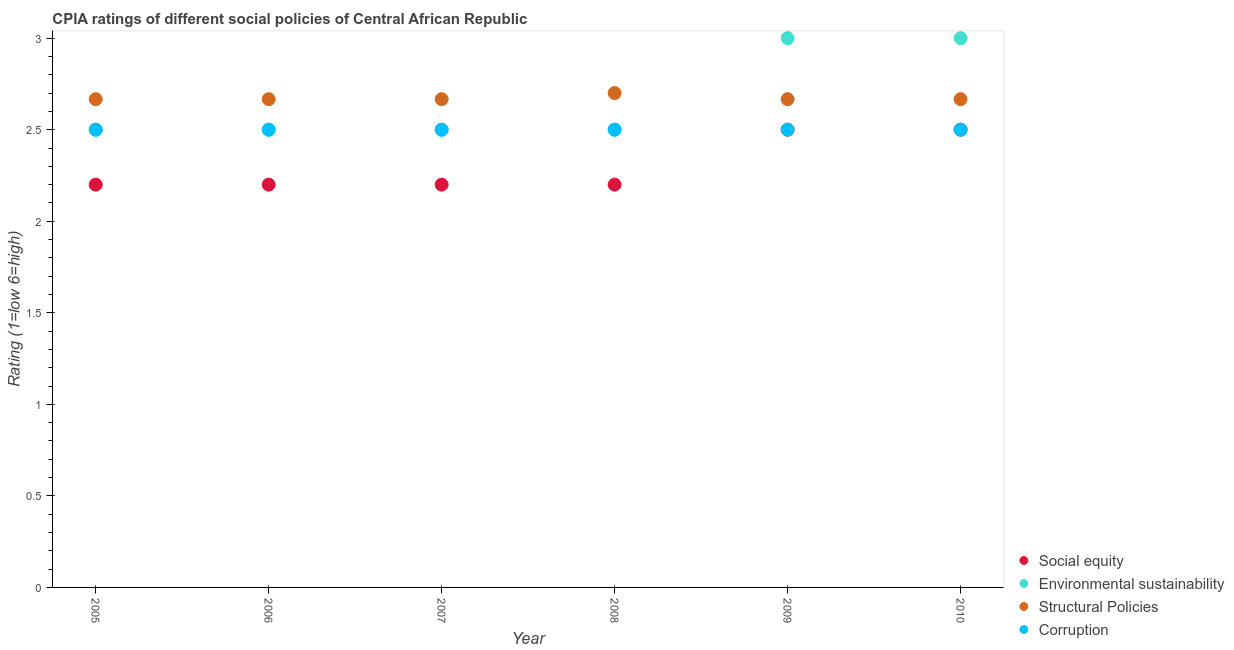Is the number of dotlines equal to the number of legend labels?
Provide a succinct answer. Yes. What is the cpia rating of corruption in 2009?
Offer a very short reply. 2.5. Across all years, what is the maximum cpia rating of structural policies?
Make the answer very short. 2.7. Across all years, what is the minimum cpia rating of structural policies?
Make the answer very short. 2.67. In which year was the cpia rating of social equity maximum?
Offer a terse response. 2009. What is the total cpia rating of structural policies in the graph?
Offer a terse response. 16.03. What is the difference between the cpia rating of social equity in 2006 and that in 2010?
Your answer should be compact. -0.3. What is the difference between the cpia rating of structural policies in 2009 and the cpia rating of social equity in 2005?
Keep it short and to the point. 0.47. What is the average cpia rating of structural policies per year?
Your answer should be compact. 2.67. In the year 2008, what is the difference between the cpia rating of social equity and cpia rating of corruption?
Your answer should be very brief. -0.3. In how many years, is the cpia rating of structural policies greater than 2.7?
Offer a terse response. 0. What is the ratio of the cpia rating of social equity in 2007 to that in 2009?
Offer a very short reply. 0.88. Is the cpia rating of structural policies in 2006 less than that in 2010?
Make the answer very short. No. Is the sum of the cpia rating of structural policies in 2006 and 2008 greater than the maximum cpia rating of corruption across all years?
Your response must be concise. Yes. Is it the case that in every year, the sum of the cpia rating of corruption and cpia rating of structural policies is greater than the sum of cpia rating of environmental sustainability and cpia rating of social equity?
Offer a very short reply. Yes. Is it the case that in every year, the sum of the cpia rating of social equity and cpia rating of environmental sustainability is greater than the cpia rating of structural policies?
Offer a very short reply. Yes. Does the cpia rating of social equity monotonically increase over the years?
Your answer should be compact. No. How many dotlines are there?
Your answer should be compact. 4. How many years are there in the graph?
Offer a terse response. 6. Does the graph contain grids?
Provide a succinct answer. No. How many legend labels are there?
Offer a terse response. 4. How are the legend labels stacked?
Provide a succinct answer. Vertical. What is the title of the graph?
Offer a terse response. CPIA ratings of different social policies of Central African Republic. What is the label or title of the Y-axis?
Give a very brief answer. Rating (1=low 6=high). What is the Rating (1=low 6=high) of Social equity in 2005?
Keep it short and to the point. 2.2. What is the Rating (1=low 6=high) of Environmental sustainability in 2005?
Your answer should be compact. 2.5. What is the Rating (1=low 6=high) of Structural Policies in 2005?
Your answer should be very brief. 2.67. What is the Rating (1=low 6=high) in Environmental sustainability in 2006?
Your response must be concise. 2.5. What is the Rating (1=low 6=high) in Structural Policies in 2006?
Give a very brief answer. 2.67. What is the Rating (1=low 6=high) in Environmental sustainability in 2007?
Give a very brief answer. 2.5. What is the Rating (1=low 6=high) of Structural Policies in 2007?
Make the answer very short. 2.67. What is the Rating (1=low 6=high) in Corruption in 2007?
Your response must be concise. 2.5. What is the Rating (1=low 6=high) in Structural Policies in 2008?
Your answer should be very brief. 2.7. What is the Rating (1=low 6=high) in Corruption in 2008?
Give a very brief answer. 2.5. What is the Rating (1=low 6=high) in Environmental sustainability in 2009?
Ensure brevity in your answer.  3. What is the Rating (1=low 6=high) of Structural Policies in 2009?
Your answer should be compact. 2.67. What is the Rating (1=low 6=high) in Corruption in 2009?
Provide a succinct answer. 2.5. What is the Rating (1=low 6=high) of Social equity in 2010?
Make the answer very short. 2.5. What is the Rating (1=low 6=high) in Environmental sustainability in 2010?
Your answer should be compact. 3. What is the Rating (1=low 6=high) in Structural Policies in 2010?
Your answer should be very brief. 2.67. Across all years, what is the maximum Rating (1=low 6=high) in Environmental sustainability?
Keep it short and to the point. 3. Across all years, what is the maximum Rating (1=low 6=high) of Corruption?
Provide a succinct answer. 2.5. Across all years, what is the minimum Rating (1=low 6=high) of Social equity?
Your response must be concise. 2.2. Across all years, what is the minimum Rating (1=low 6=high) of Environmental sustainability?
Your answer should be compact. 2.5. Across all years, what is the minimum Rating (1=low 6=high) in Structural Policies?
Ensure brevity in your answer.  2.67. Across all years, what is the minimum Rating (1=low 6=high) in Corruption?
Your answer should be compact. 2.5. What is the total Rating (1=low 6=high) in Social equity in the graph?
Offer a terse response. 13.8. What is the total Rating (1=low 6=high) of Structural Policies in the graph?
Offer a terse response. 16.03. What is the total Rating (1=low 6=high) of Corruption in the graph?
Give a very brief answer. 15. What is the difference between the Rating (1=low 6=high) of Social equity in 2005 and that in 2006?
Your answer should be compact. 0. What is the difference between the Rating (1=low 6=high) in Environmental sustainability in 2005 and that in 2006?
Provide a short and direct response. 0. What is the difference between the Rating (1=low 6=high) in Structural Policies in 2005 and that in 2006?
Provide a short and direct response. 0. What is the difference between the Rating (1=low 6=high) of Corruption in 2005 and that in 2006?
Keep it short and to the point. 0. What is the difference between the Rating (1=low 6=high) in Environmental sustainability in 2005 and that in 2007?
Your answer should be compact. 0. What is the difference between the Rating (1=low 6=high) in Corruption in 2005 and that in 2007?
Keep it short and to the point. 0. What is the difference between the Rating (1=low 6=high) of Social equity in 2005 and that in 2008?
Give a very brief answer. 0. What is the difference between the Rating (1=low 6=high) of Environmental sustainability in 2005 and that in 2008?
Make the answer very short. 0. What is the difference between the Rating (1=low 6=high) in Structural Policies in 2005 and that in 2008?
Your response must be concise. -0.03. What is the difference between the Rating (1=low 6=high) in Corruption in 2005 and that in 2008?
Offer a very short reply. 0. What is the difference between the Rating (1=low 6=high) in Structural Policies in 2005 and that in 2009?
Provide a short and direct response. 0. What is the difference between the Rating (1=low 6=high) in Corruption in 2005 and that in 2009?
Provide a succinct answer. 0. What is the difference between the Rating (1=low 6=high) in Corruption in 2005 and that in 2010?
Offer a very short reply. 0. What is the difference between the Rating (1=low 6=high) of Social equity in 2006 and that in 2007?
Offer a terse response. 0. What is the difference between the Rating (1=low 6=high) in Environmental sustainability in 2006 and that in 2007?
Your answer should be very brief. 0. What is the difference between the Rating (1=low 6=high) of Corruption in 2006 and that in 2007?
Ensure brevity in your answer.  0. What is the difference between the Rating (1=low 6=high) in Structural Policies in 2006 and that in 2008?
Keep it short and to the point. -0.03. What is the difference between the Rating (1=low 6=high) in Structural Policies in 2006 and that in 2009?
Ensure brevity in your answer.  0. What is the difference between the Rating (1=low 6=high) in Social equity in 2006 and that in 2010?
Offer a terse response. -0.3. What is the difference between the Rating (1=low 6=high) in Corruption in 2006 and that in 2010?
Provide a succinct answer. 0. What is the difference between the Rating (1=low 6=high) of Social equity in 2007 and that in 2008?
Provide a succinct answer. 0. What is the difference between the Rating (1=low 6=high) of Structural Policies in 2007 and that in 2008?
Give a very brief answer. -0.03. What is the difference between the Rating (1=low 6=high) in Structural Policies in 2007 and that in 2009?
Your answer should be very brief. 0. What is the difference between the Rating (1=low 6=high) in Corruption in 2007 and that in 2009?
Offer a terse response. 0. What is the difference between the Rating (1=low 6=high) of Social equity in 2007 and that in 2010?
Provide a short and direct response. -0.3. What is the difference between the Rating (1=low 6=high) in Environmental sustainability in 2007 and that in 2010?
Your answer should be compact. -0.5. What is the difference between the Rating (1=low 6=high) in Structural Policies in 2007 and that in 2010?
Give a very brief answer. 0. What is the difference between the Rating (1=low 6=high) in Corruption in 2007 and that in 2010?
Make the answer very short. 0. What is the difference between the Rating (1=low 6=high) in Structural Policies in 2008 and that in 2009?
Offer a terse response. 0.03. What is the difference between the Rating (1=low 6=high) of Corruption in 2008 and that in 2009?
Keep it short and to the point. 0. What is the difference between the Rating (1=low 6=high) in Environmental sustainability in 2008 and that in 2010?
Your answer should be compact. -0.5. What is the difference between the Rating (1=low 6=high) in Structural Policies in 2009 and that in 2010?
Your answer should be compact. 0. What is the difference between the Rating (1=low 6=high) in Social equity in 2005 and the Rating (1=low 6=high) in Structural Policies in 2006?
Offer a terse response. -0.47. What is the difference between the Rating (1=low 6=high) in Structural Policies in 2005 and the Rating (1=low 6=high) in Corruption in 2006?
Your answer should be very brief. 0.17. What is the difference between the Rating (1=low 6=high) of Social equity in 2005 and the Rating (1=low 6=high) of Environmental sustainability in 2007?
Make the answer very short. -0.3. What is the difference between the Rating (1=low 6=high) in Social equity in 2005 and the Rating (1=low 6=high) in Structural Policies in 2007?
Provide a short and direct response. -0.47. What is the difference between the Rating (1=low 6=high) in Environmental sustainability in 2005 and the Rating (1=low 6=high) in Corruption in 2007?
Make the answer very short. 0. What is the difference between the Rating (1=low 6=high) of Structural Policies in 2005 and the Rating (1=low 6=high) of Corruption in 2007?
Your answer should be compact. 0.17. What is the difference between the Rating (1=low 6=high) in Structural Policies in 2005 and the Rating (1=low 6=high) in Corruption in 2008?
Provide a short and direct response. 0.17. What is the difference between the Rating (1=low 6=high) in Social equity in 2005 and the Rating (1=low 6=high) in Environmental sustainability in 2009?
Ensure brevity in your answer.  -0.8. What is the difference between the Rating (1=low 6=high) in Social equity in 2005 and the Rating (1=low 6=high) in Structural Policies in 2009?
Offer a very short reply. -0.47. What is the difference between the Rating (1=low 6=high) of Social equity in 2005 and the Rating (1=low 6=high) of Corruption in 2009?
Your answer should be very brief. -0.3. What is the difference between the Rating (1=low 6=high) of Environmental sustainability in 2005 and the Rating (1=low 6=high) of Corruption in 2009?
Ensure brevity in your answer.  0. What is the difference between the Rating (1=low 6=high) of Structural Policies in 2005 and the Rating (1=low 6=high) of Corruption in 2009?
Your response must be concise. 0.17. What is the difference between the Rating (1=low 6=high) in Social equity in 2005 and the Rating (1=low 6=high) in Environmental sustainability in 2010?
Give a very brief answer. -0.8. What is the difference between the Rating (1=low 6=high) in Social equity in 2005 and the Rating (1=low 6=high) in Structural Policies in 2010?
Keep it short and to the point. -0.47. What is the difference between the Rating (1=low 6=high) in Environmental sustainability in 2005 and the Rating (1=low 6=high) in Structural Policies in 2010?
Your answer should be compact. -0.17. What is the difference between the Rating (1=low 6=high) of Social equity in 2006 and the Rating (1=low 6=high) of Environmental sustainability in 2007?
Ensure brevity in your answer.  -0.3. What is the difference between the Rating (1=low 6=high) of Social equity in 2006 and the Rating (1=low 6=high) of Structural Policies in 2007?
Offer a terse response. -0.47. What is the difference between the Rating (1=low 6=high) of Social equity in 2006 and the Rating (1=low 6=high) of Corruption in 2007?
Your response must be concise. -0.3. What is the difference between the Rating (1=low 6=high) in Environmental sustainability in 2006 and the Rating (1=low 6=high) in Structural Policies in 2007?
Keep it short and to the point. -0.17. What is the difference between the Rating (1=low 6=high) of Environmental sustainability in 2006 and the Rating (1=low 6=high) of Corruption in 2007?
Your answer should be very brief. 0. What is the difference between the Rating (1=low 6=high) of Social equity in 2006 and the Rating (1=low 6=high) of Environmental sustainability in 2008?
Your answer should be compact. -0.3. What is the difference between the Rating (1=low 6=high) in Environmental sustainability in 2006 and the Rating (1=low 6=high) in Corruption in 2008?
Make the answer very short. 0. What is the difference between the Rating (1=low 6=high) of Social equity in 2006 and the Rating (1=low 6=high) of Structural Policies in 2009?
Provide a short and direct response. -0.47. What is the difference between the Rating (1=low 6=high) of Environmental sustainability in 2006 and the Rating (1=low 6=high) of Structural Policies in 2009?
Make the answer very short. -0.17. What is the difference between the Rating (1=low 6=high) in Structural Policies in 2006 and the Rating (1=low 6=high) in Corruption in 2009?
Ensure brevity in your answer.  0.17. What is the difference between the Rating (1=low 6=high) in Social equity in 2006 and the Rating (1=low 6=high) in Structural Policies in 2010?
Offer a very short reply. -0.47. What is the difference between the Rating (1=low 6=high) in Social equity in 2006 and the Rating (1=low 6=high) in Corruption in 2010?
Keep it short and to the point. -0.3. What is the difference between the Rating (1=low 6=high) of Environmental sustainability in 2006 and the Rating (1=low 6=high) of Structural Policies in 2010?
Provide a short and direct response. -0.17. What is the difference between the Rating (1=low 6=high) in Social equity in 2007 and the Rating (1=low 6=high) in Environmental sustainability in 2008?
Your answer should be very brief. -0.3. What is the difference between the Rating (1=low 6=high) of Social equity in 2007 and the Rating (1=low 6=high) of Structural Policies in 2008?
Make the answer very short. -0.5. What is the difference between the Rating (1=low 6=high) of Structural Policies in 2007 and the Rating (1=low 6=high) of Corruption in 2008?
Your answer should be very brief. 0.17. What is the difference between the Rating (1=low 6=high) in Social equity in 2007 and the Rating (1=low 6=high) in Structural Policies in 2009?
Provide a short and direct response. -0.47. What is the difference between the Rating (1=low 6=high) of Social equity in 2007 and the Rating (1=low 6=high) of Corruption in 2009?
Ensure brevity in your answer.  -0.3. What is the difference between the Rating (1=low 6=high) in Structural Policies in 2007 and the Rating (1=low 6=high) in Corruption in 2009?
Your answer should be very brief. 0.17. What is the difference between the Rating (1=low 6=high) in Social equity in 2007 and the Rating (1=low 6=high) in Environmental sustainability in 2010?
Provide a succinct answer. -0.8. What is the difference between the Rating (1=low 6=high) of Social equity in 2007 and the Rating (1=low 6=high) of Structural Policies in 2010?
Give a very brief answer. -0.47. What is the difference between the Rating (1=low 6=high) of Social equity in 2007 and the Rating (1=low 6=high) of Corruption in 2010?
Offer a very short reply. -0.3. What is the difference between the Rating (1=low 6=high) in Environmental sustainability in 2007 and the Rating (1=low 6=high) in Structural Policies in 2010?
Your answer should be very brief. -0.17. What is the difference between the Rating (1=low 6=high) in Social equity in 2008 and the Rating (1=low 6=high) in Structural Policies in 2009?
Provide a succinct answer. -0.47. What is the difference between the Rating (1=low 6=high) in Social equity in 2008 and the Rating (1=low 6=high) in Corruption in 2009?
Offer a very short reply. -0.3. What is the difference between the Rating (1=low 6=high) of Environmental sustainability in 2008 and the Rating (1=low 6=high) of Structural Policies in 2009?
Keep it short and to the point. -0.17. What is the difference between the Rating (1=low 6=high) of Social equity in 2008 and the Rating (1=low 6=high) of Environmental sustainability in 2010?
Your answer should be compact. -0.8. What is the difference between the Rating (1=low 6=high) in Social equity in 2008 and the Rating (1=low 6=high) in Structural Policies in 2010?
Give a very brief answer. -0.47. What is the difference between the Rating (1=low 6=high) of Environmental sustainability in 2008 and the Rating (1=low 6=high) of Structural Policies in 2010?
Your response must be concise. -0.17. What is the difference between the Rating (1=low 6=high) in Environmental sustainability in 2008 and the Rating (1=low 6=high) in Corruption in 2010?
Offer a terse response. 0. What is the difference between the Rating (1=low 6=high) of Structural Policies in 2008 and the Rating (1=low 6=high) of Corruption in 2010?
Offer a terse response. 0.2. What is the difference between the Rating (1=low 6=high) in Social equity in 2009 and the Rating (1=low 6=high) in Environmental sustainability in 2010?
Your answer should be compact. -0.5. What is the difference between the Rating (1=low 6=high) in Social equity in 2009 and the Rating (1=low 6=high) in Structural Policies in 2010?
Your answer should be compact. -0.17. What is the average Rating (1=low 6=high) of Social equity per year?
Keep it short and to the point. 2.3. What is the average Rating (1=low 6=high) in Environmental sustainability per year?
Your answer should be very brief. 2.67. What is the average Rating (1=low 6=high) of Structural Policies per year?
Your answer should be compact. 2.67. What is the average Rating (1=low 6=high) of Corruption per year?
Make the answer very short. 2.5. In the year 2005, what is the difference between the Rating (1=low 6=high) of Social equity and Rating (1=low 6=high) of Structural Policies?
Give a very brief answer. -0.47. In the year 2005, what is the difference between the Rating (1=low 6=high) in Social equity and Rating (1=low 6=high) in Corruption?
Your answer should be compact. -0.3. In the year 2005, what is the difference between the Rating (1=low 6=high) in Environmental sustainability and Rating (1=low 6=high) in Structural Policies?
Give a very brief answer. -0.17. In the year 2005, what is the difference between the Rating (1=low 6=high) in Environmental sustainability and Rating (1=low 6=high) in Corruption?
Make the answer very short. 0. In the year 2005, what is the difference between the Rating (1=low 6=high) of Structural Policies and Rating (1=low 6=high) of Corruption?
Make the answer very short. 0.17. In the year 2006, what is the difference between the Rating (1=low 6=high) in Social equity and Rating (1=low 6=high) in Environmental sustainability?
Provide a short and direct response. -0.3. In the year 2006, what is the difference between the Rating (1=low 6=high) of Social equity and Rating (1=low 6=high) of Structural Policies?
Offer a terse response. -0.47. In the year 2006, what is the difference between the Rating (1=low 6=high) in Structural Policies and Rating (1=low 6=high) in Corruption?
Your answer should be compact. 0.17. In the year 2007, what is the difference between the Rating (1=low 6=high) in Social equity and Rating (1=low 6=high) in Structural Policies?
Your answer should be very brief. -0.47. In the year 2007, what is the difference between the Rating (1=low 6=high) in Social equity and Rating (1=low 6=high) in Corruption?
Ensure brevity in your answer.  -0.3. In the year 2007, what is the difference between the Rating (1=low 6=high) in Environmental sustainability and Rating (1=low 6=high) in Corruption?
Provide a short and direct response. 0. In the year 2008, what is the difference between the Rating (1=low 6=high) in Environmental sustainability and Rating (1=low 6=high) in Structural Policies?
Your answer should be very brief. -0.2. In the year 2008, what is the difference between the Rating (1=low 6=high) in Environmental sustainability and Rating (1=low 6=high) in Corruption?
Keep it short and to the point. 0. In the year 2009, what is the difference between the Rating (1=low 6=high) of Social equity and Rating (1=low 6=high) of Corruption?
Your answer should be compact. 0. In the year 2009, what is the difference between the Rating (1=low 6=high) in Structural Policies and Rating (1=low 6=high) in Corruption?
Provide a succinct answer. 0.17. In the year 2010, what is the difference between the Rating (1=low 6=high) of Social equity and Rating (1=low 6=high) of Environmental sustainability?
Offer a very short reply. -0.5. In the year 2010, what is the difference between the Rating (1=low 6=high) in Social equity and Rating (1=low 6=high) in Corruption?
Keep it short and to the point. 0. In the year 2010, what is the difference between the Rating (1=low 6=high) in Environmental sustainability and Rating (1=low 6=high) in Structural Policies?
Your answer should be compact. 0.33. In the year 2010, what is the difference between the Rating (1=low 6=high) in Structural Policies and Rating (1=low 6=high) in Corruption?
Your response must be concise. 0.17. What is the ratio of the Rating (1=low 6=high) in Social equity in 2005 to that in 2006?
Offer a very short reply. 1. What is the ratio of the Rating (1=low 6=high) in Structural Policies in 2005 to that in 2006?
Make the answer very short. 1. What is the ratio of the Rating (1=low 6=high) of Corruption in 2005 to that in 2006?
Provide a succinct answer. 1. What is the ratio of the Rating (1=low 6=high) of Structural Policies in 2005 to that in 2007?
Your answer should be compact. 1. What is the ratio of the Rating (1=low 6=high) of Corruption in 2005 to that in 2007?
Provide a succinct answer. 1. What is the ratio of the Rating (1=low 6=high) in Social equity in 2005 to that in 2008?
Make the answer very short. 1. What is the ratio of the Rating (1=low 6=high) in Corruption in 2005 to that in 2009?
Provide a succinct answer. 1. What is the ratio of the Rating (1=low 6=high) of Social equity in 2005 to that in 2010?
Provide a short and direct response. 0.88. What is the ratio of the Rating (1=low 6=high) of Environmental sustainability in 2005 to that in 2010?
Provide a short and direct response. 0.83. What is the ratio of the Rating (1=low 6=high) of Social equity in 2006 to that in 2007?
Provide a short and direct response. 1. What is the ratio of the Rating (1=low 6=high) of Corruption in 2006 to that in 2007?
Keep it short and to the point. 1. What is the ratio of the Rating (1=low 6=high) of Social equity in 2006 to that in 2008?
Ensure brevity in your answer.  1. What is the ratio of the Rating (1=low 6=high) in Environmental sustainability in 2006 to that in 2008?
Your response must be concise. 1. What is the ratio of the Rating (1=low 6=high) in Structural Policies in 2006 to that in 2008?
Your response must be concise. 0.99. What is the ratio of the Rating (1=low 6=high) of Social equity in 2006 to that in 2009?
Ensure brevity in your answer.  0.88. What is the ratio of the Rating (1=low 6=high) in Environmental sustainability in 2006 to that in 2009?
Offer a terse response. 0.83. What is the ratio of the Rating (1=low 6=high) in Corruption in 2006 to that in 2009?
Your answer should be very brief. 1. What is the ratio of the Rating (1=low 6=high) of Environmental sustainability in 2006 to that in 2010?
Offer a terse response. 0.83. What is the ratio of the Rating (1=low 6=high) of Structural Policies in 2006 to that in 2010?
Keep it short and to the point. 1. What is the ratio of the Rating (1=low 6=high) in Social equity in 2007 to that in 2008?
Your answer should be very brief. 1. What is the ratio of the Rating (1=low 6=high) of Environmental sustainability in 2007 to that in 2008?
Your response must be concise. 1. What is the ratio of the Rating (1=low 6=high) of Structural Policies in 2007 to that in 2008?
Provide a short and direct response. 0.99. What is the ratio of the Rating (1=low 6=high) in Corruption in 2007 to that in 2008?
Offer a very short reply. 1. What is the ratio of the Rating (1=low 6=high) of Environmental sustainability in 2007 to that in 2009?
Ensure brevity in your answer.  0.83. What is the ratio of the Rating (1=low 6=high) in Structural Policies in 2007 to that in 2009?
Offer a very short reply. 1. What is the ratio of the Rating (1=low 6=high) of Social equity in 2007 to that in 2010?
Make the answer very short. 0.88. What is the ratio of the Rating (1=low 6=high) in Environmental sustainability in 2007 to that in 2010?
Make the answer very short. 0.83. What is the ratio of the Rating (1=low 6=high) in Social equity in 2008 to that in 2009?
Offer a very short reply. 0.88. What is the ratio of the Rating (1=low 6=high) of Structural Policies in 2008 to that in 2009?
Make the answer very short. 1.01. What is the ratio of the Rating (1=low 6=high) of Environmental sustainability in 2008 to that in 2010?
Offer a terse response. 0.83. What is the ratio of the Rating (1=low 6=high) of Structural Policies in 2008 to that in 2010?
Ensure brevity in your answer.  1.01. What is the ratio of the Rating (1=low 6=high) of Corruption in 2008 to that in 2010?
Your response must be concise. 1. What is the ratio of the Rating (1=low 6=high) in Social equity in 2009 to that in 2010?
Give a very brief answer. 1. What is the ratio of the Rating (1=low 6=high) in Environmental sustainability in 2009 to that in 2010?
Keep it short and to the point. 1. What is the ratio of the Rating (1=low 6=high) of Corruption in 2009 to that in 2010?
Keep it short and to the point. 1. What is the difference between the highest and the second highest Rating (1=low 6=high) of Environmental sustainability?
Give a very brief answer. 0. What is the difference between the highest and the second highest Rating (1=low 6=high) of Corruption?
Keep it short and to the point. 0. What is the difference between the highest and the lowest Rating (1=low 6=high) of Corruption?
Your answer should be very brief. 0. 